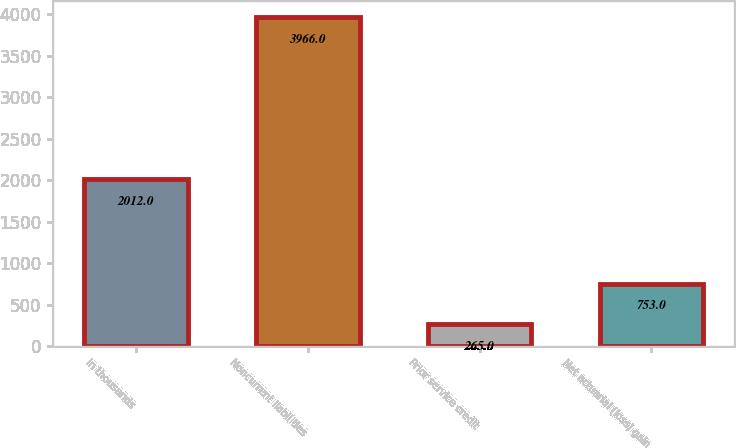Convert chart to OTSL. <chart><loc_0><loc_0><loc_500><loc_500><bar_chart><fcel>In thousands<fcel>Noncurrent liabilities<fcel>Prior service credit<fcel>Net actuarial (loss) gain<nl><fcel>2012<fcel>3966<fcel>265<fcel>753<nl></chart> 